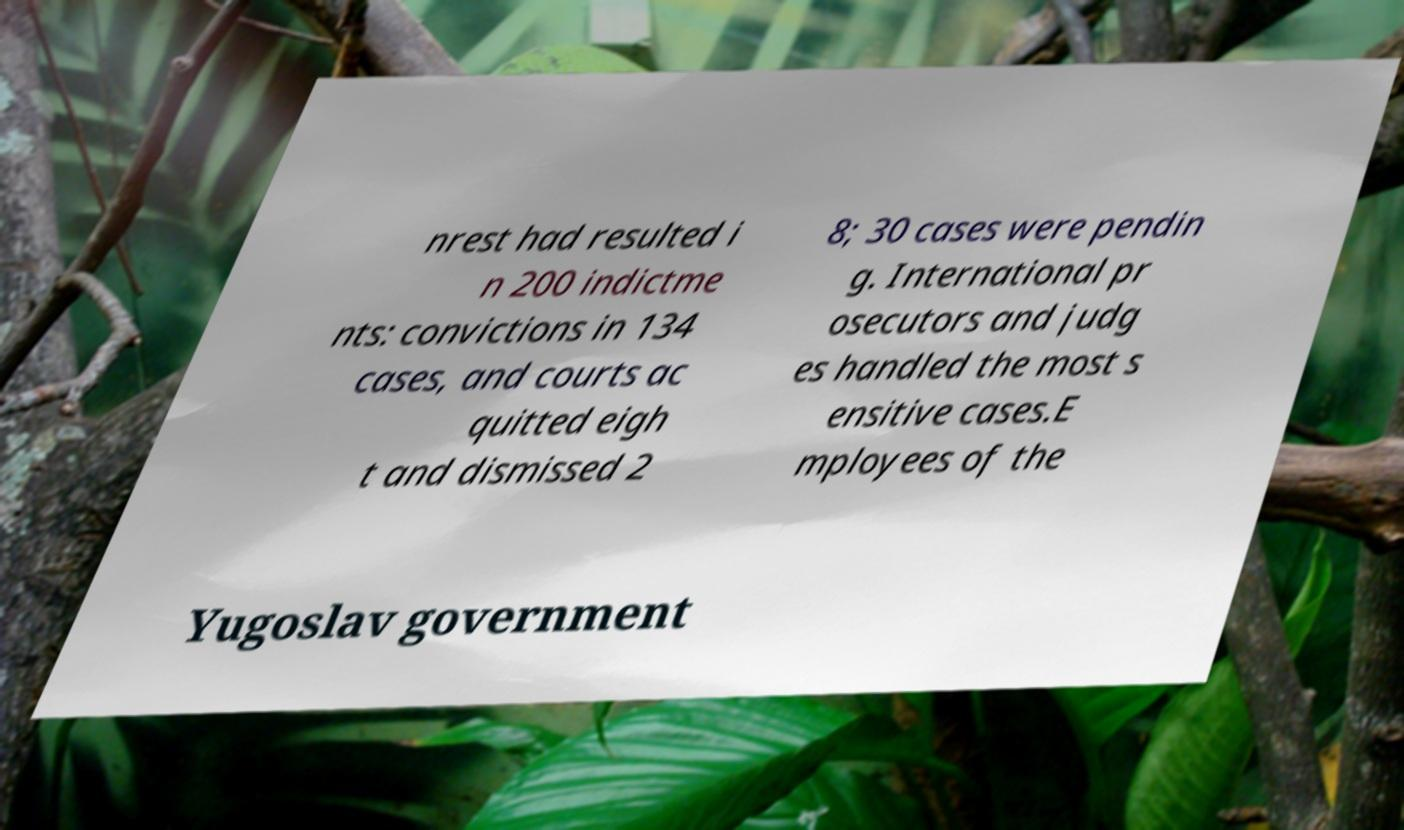For documentation purposes, I need the text within this image transcribed. Could you provide that? nrest had resulted i n 200 indictme nts: convictions in 134 cases, and courts ac quitted eigh t and dismissed 2 8; 30 cases were pendin g. International pr osecutors and judg es handled the most s ensitive cases.E mployees of the Yugoslav government 